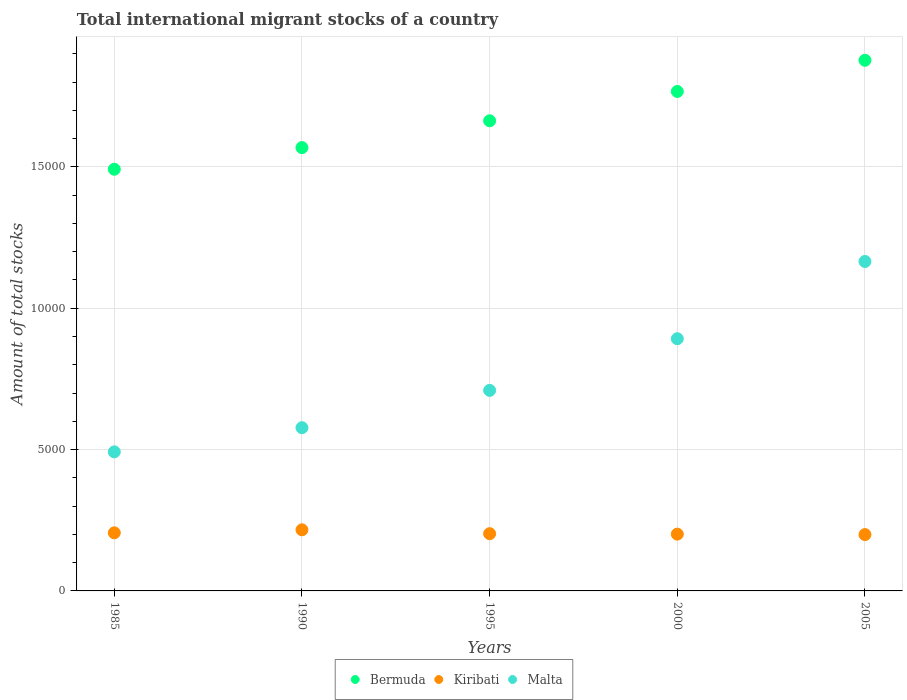What is the amount of total stocks in in Kiribati in 1985?
Offer a very short reply. 2055. Across all years, what is the maximum amount of total stocks in in Bermuda?
Provide a succinct answer. 1.88e+04. What is the total amount of total stocks in in Malta in the graph?
Keep it short and to the point. 3.84e+04. What is the difference between the amount of total stocks in in Bermuda in 1985 and that in 2000?
Keep it short and to the point. -2751. What is the difference between the amount of total stocks in in Kiribati in 1985 and the amount of total stocks in in Bermuda in 2000?
Ensure brevity in your answer.  -1.56e+04. What is the average amount of total stocks in in Kiribati per year?
Your answer should be very brief. 2048.8. In the year 1985, what is the difference between the amount of total stocks in in Kiribati and amount of total stocks in in Malta?
Provide a short and direct response. -2864. In how many years, is the amount of total stocks in in Malta greater than 4000?
Your answer should be compact. 5. What is the ratio of the amount of total stocks in in Bermuda in 1985 to that in 2005?
Your response must be concise. 0.79. Is the amount of total stocks in in Malta in 1985 less than that in 1995?
Provide a succinct answer. Yes. Is the difference between the amount of total stocks in in Kiribati in 1985 and 2000 greater than the difference between the amount of total stocks in in Malta in 1985 and 2000?
Provide a short and direct response. Yes. What is the difference between the highest and the second highest amount of total stocks in in Bermuda?
Make the answer very short. 1103. What is the difference between the highest and the lowest amount of total stocks in in Bermuda?
Ensure brevity in your answer.  3854. Is the sum of the amount of total stocks in in Bermuda in 1995 and 2005 greater than the maximum amount of total stocks in in Kiribati across all years?
Provide a short and direct response. Yes. Does the amount of total stocks in in Kiribati monotonically increase over the years?
Provide a succinct answer. No. Is the amount of total stocks in in Bermuda strictly less than the amount of total stocks in in Malta over the years?
Make the answer very short. No. How many dotlines are there?
Ensure brevity in your answer.  3. How many years are there in the graph?
Provide a succinct answer. 5. Are the values on the major ticks of Y-axis written in scientific E-notation?
Offer a terse response. No. How many legend labels are there?
Make the answer very short. 3. What is the title of the graph?
Provide a succinct answer. Total international migrant stocks of a country. Does "Hungary" appear as one of the legend labels in the graph?
Keep it short and to the point. No. What is the label or title of the X-axis?
Your answer should be very brief. Years. What is the label or title of the Y-axis?
Give a very brief answer. Amount of total stocks. What is the Amount of total stocks of Bermuda in 1985?
Ensure brevity in your answer.  1.49e+04. What is the Amount of total stocks in Kiribati in 1985?
Your answer should be very brief. 2055. What is the Amount of total stocks of Malta in 1985?
Offer a terse response. 4919. What is the Amount of total stocks in Bermuda in 1990?
Ensure brevity in your answer.  1.57e+04. What is the Amount of total stocks of Kiribati in 1990?
Keep it short and to the point. 2162. What is the Amount of total stocks of Malta in 1990?
Give a very brief answer. 5774. What is the Amount of total stocks in Bermuda in 1995?
Your response must be concise. 1.66e+04. What is the Amount of total stocks of Kiribati in 1995?
Keep it short and to the point. 2025. What is the Amount of total stocks in Malta in 1995?
Provide a succinct answer. 7094. What is the Amount of total stocks in Bermuda in 2000?
Your response must be concise. 1.77e+04. What is the Amount of total stocks in Kiribati in 2000?
Offer a terse response. 2009. What is the Amount of total stocks in Malta in 2000?
Ensure brevity in your answer.  8922. What is the Amount of total stocks in Bermuda in 2005?
Give a very brief answer. 1.88e+04. What is the Amount of total stocks in Kiribati in 2005?
Your answer should be very brief. 1993. What is the Amount of total stocks in Malta in 2005?
Provide a short and direct response. 1.17e+04. Across all years, what is the maximum Amount of total stocks in Bermuda?
Provide a succinct answer. 1.88e+04. Across all years, what is the maximum Amount of total stocks in Kiribati?
Keep it short and to the point. 2162. Across all years, what is the maximum Amount of total stocks in Malta?
Give a very brief answer. 1.17e+04. Across all years, what is the minimum Amount of total stocks of Bermuda?
Your answer should be very brief. 1.49e+04. Across all years, what is the minimum Amount of total stocks in Kiribati?
Provide a succinct answer. 1993. Across all years, what is the minimum Amount of total stocks in Malta?
Offer a very short reply. 4919. What is the total Amount of total stocks in Bermuda in the graph?
Keep it short and to the point. 8.37e+04. What is the total Amount of total stocks of Kiribati in the graph?
Offer a very short reply. 1.02e+04. What is the total Amount of total stocks of Malta in the graph?
Give a very brief answer. 3.84e+04. What is the difference between the Amount of total stocks in Bermuda in 1985 and that in 1990?
Give a very brief answer. -766. What is the difference between the Amount of total stocks in Kiribati in 1985 and that in 1990?
Ensure brevity in your answer.  -107. What is the difference between the Amount of total stocks in Malta in 1985 and that in 1990?
Your answer should be compact. -855. What is the difference between the Amount of total stocks of Bermuda in 1985 and that in 1995?
Ensure brevity in your answer.  -1714. What is the difference between the Amount of total stocks in Malta in 1985 and that in 1995?
Offer a terse response. -2175. What is the difference between the Amount of total stocks of Bermuda in 1985 and that in 2000?
Your answer should be compact. -2751. What is the difference between the Amount of total stocks in Malta in 1985 and that in 2000?
Make the answer very short. -4003. What is the difference between the Amount of total stocks of Bermuda in 1985 and that in 2005?
Give a very brief answer. -3854. What is the difference between the Amount of total stocks in Kiribati in 1985 and that in 2005?
Keep it short and to the point. 62. What is the difference between the Amount of total stocks in Malta in 1985 and that in 2005?
Your answer should be very brief. -6735. What is the difference between the Amount of total stocks in Bermuda in 1990 and that in 1995?
Your answer should be compact. -948. What is the difference between the Amount of total stocks in Kiribati in 1990 and that in 1995?
Provide a succinct answer. 137. What is the difference between the Amount of total stocks of Malta in 1990 and that in 1995?
Offer a very short reply. -1320. What is the difference between the Amount of total stocks in Bermuda in 1990 and that in 2000?
Give a very brief answer. -1985. What is the difference between the Amount of total stocks in Kiribati in 1990 and that in 2000?
Give a very brief answer. 153. What is the difference between the Amount of total stocks of Malta in 1990 and that in 2000?
Your answer should be compact. -3148. What is the difference between the Amount of total stocks of Bermuda in 1990 and that in 2005?
Your response must be concise. -3088. What is the difference between the Amount of total stocks in Kiribati in 1990 and that in 2005?
Keep it short and to the point. 169. What is the difference between the Amount of total stocks of Malta in 1990 and that in 2005?
Make the answer very short. -5880. What is the difference between the Amount of total stocks of Bermuda in 1995 and that in 2000?
Ensure brevity in your answer.  -1037. What is the difference between the Amount of total stocks in Kiribati in 1995 and that in 2000?
Provide a succinct answer. 16. What is the difference between the Amount of total stocks of Malta in 1995 and that in 2000?
Give a very brief answer. -1828. What is the difference between the Amount of total stocks in Bermuda in 1995 and that in 2005?
Offer a terse response. -2140. What is the difference between the Amount of total stocks of Kiribati in 1995 and that in 2005?
Make the answer very short. 32. What is the difference between the Amount of total stocks in Malta in 1995 and that in 2005?
Your answer should be very brief. -4560. What is the difference between the Amount of total stocks in Bermuda in 2000 and that in 2005?
Give a very brief answer. -1103. What is the difference between the Amount of total stocks in Malta in 2000 and that in 2005?
Ensure brevity in your answer.  -2732. What is the difference between the Amount of total stocks in Bermuda in 1985 and the Amount of total stocks in Kiribati in 1990?
Provide a succinct answer. 1.28e+04. What is the difference between the Amount of total stocks of Bermuda in 1985 and the Amount of total stocks of Malta in 1990?
Provide a short and direct response. 9143. What is the difference between the Amount of total stocks in Kiribati in 1985 and the Amount of total stocks in Malta in 1990?
Your answer should be compact. -3719. What is the difference between the Amount of total stocks of Bermuda in 1985 and the Amount of total stocks of Kiribati in 1995?
Ensure brevity in your answer.  1.29e+04. What is the difference between the Amount of total stocks in Bermuda in 1985 and the Amount of total stocks in Malta in 1995?
Keep it short and to the point. 7823. What is the difference between the Amount of total stocks in Kiribati in 1985 and the Amount of total stocks in Malta in 1995?
Make the answer very short. -5039. What is the difference between the Amount of total stocks in Bermuda in 1985 and the Amount of total stocks in Kiribati in 2000?
Offer a very short reply. 1.29e+04. What is the difference between the Amount of total stocks in Bermuda in 1985 and the Amount of total stocks in Malta in 2000?
Provide a short and direct response. 5995. What is the difference between the Amount of total stocks in Kiribati in 1985 and the Amount of total stocks in Malta in 2000?
Your answer should be very brief. -6867. What is the difference between the Amount of total stocks in Bermuda in 1985 and the Amount of total stocks in Kiribati in 2005?
Your answer should be compact. 1.29e+04. What is the difference between the Amount of total stocks of Bermuda in 1985 and the Amount of total stocks of Malta in 2005?
Give a very brief answer. 3263. What is the difference between the Amount of total stocks of Kiribati in 1985 and the Amount of total stocks of Malta in 2005?
Provide a short and direct response. -9599. What is the difference between the Amount of total stocks in Bermuda in 1990 and the Amount of total stocks in Kiribati in 1995?
Provide a succinct answer. 1.37e+04. What is the difference between the Amount of total stocks of Bermuda in 1990 and the Amount of total stocks of Malta in 1995?
Make the answer very short. 8589. What is the difference between the Amount of total stocks of Kiribati in 1990 and the Amount of total stocks of Malta in 1995?
Your answer should be compact. -4932. What is the difference between the Amount of total stocks in Bermuda in 1990 and the Amount of total stocks in Kiribati in 2000?
Offer a terse response. 1.37e+04. What is the difference between the Amount of total stocks in Bermuda in 1990 and the Amount of total stocks in Malta in 2000?
Keep it short and to the point. 6761. What is the difference between the Amount of total stocks of Kiribati in 1990 and the Amount of total stocks of Malta in 2000?
Ensure brevity in your answer.  -6760. What is the difference between the Amount of total stocks in Bermuda in 1990 and the Amount of total stocks in Kiribati in 2005?
Provide a short and direct response. 1.37e+04. What is the difference between the Amount of total stocks of Bermuda in 1990 and the Amount of total stocks of Malta in 2005?
Offer a terse response. 4029. What is the difference between the Amount of total stocks in Kiribati in 1990 and the Amount of total stocks in Malta in 2005?
Your answer should be very brief. -9492. What is the difference between the Amount of total stocks of Bermuda in 1995 and the Amount of total stocks of Kiribati in 2000?
Provide a short and direct response. 1.46e+04. What is the difference between the Amount of total stocks in Bermuda in 1995 and the Amount of total stocks in Malta in 2000?
Provide a succinct answer. 7709. What is the difference between the Amount of total stocks of Kiribati in 1995 and the Amount of total stocks of Malta in 2000?
Your answer should be compact. -6897. What is the difference between the Amount of total stocks in Bermuda in 1995 and the Amount of total stocks in Kiribati in 2005?
Your answer should be very brief. 1.46e+04. What is the difference between the Amount of total stocks of Bermuda in 1995 and the Amount of total stocks of Malta in 2005?
Your answer should be very brief. 4977. What is the difference between the Amount of total stocks of Kiribati in 1995 and the Amount of total stocks of Malta in 2005?
Ensure brevity in your answer.  -9629. What is the difference between the Amount of total stocks of Bermuda in 2000 and the Amount of total stocks of Kiribati in 2005?
Your answer should be very brief. 1.57e+04. What is the difference between the Amount of total stocks of Bermuda in 2000 and the Amount of total stocks of Malta in 2005?
Provide a short and direct response. 6014. What is the difference between the Amount of total stocks of Kiribati in 2000 and the Amount of total stocks of Malta in 2005?
Provide a succinct answer. -9645. What is the average Amount of total stocks in Bermuda per year?
Offer a terse response. 1.67e+04. What is the average Amount of total stocks of Kiribati per year?
Offer a very short reply. 2048.8. What is the average Amount of total stocks in Malta per year?
Your response must be concise. 7672.6. In the year 1985, what is the difference between the Amount of total stocks of Bermuda and Amount of total stocks of Kiribati?
Offer a very short reply. 1.29e+04. In the year 1985, what is the difference between the Amount of total stocks in Bermuda and Amount of total stocks in Malta?
Give a very brief answer. 9998. In the year 1985, what is the difference between the Amount of total stocks in Kiribati and Amount of total stocks in Malta?
Ensure brevity in your answer.  -2864. In the year 1990, what is the difference between the Amount of total stocks in Bermuda and Amount of total stocks in Kiribati?
Provide a succinct answer. 1.35e+04. In the year 1990, what is the difference between the Amount of total stocks in Bermuda and Amount of total stocks in Malta?
Your response must be concise. 9909. In the year 1990, what is the difference between the Amount of total stocks of Kiribati and Amount of total stocks of Malta?
Make the answer very short. -3612. In the year 1995, what is the difference between the Amount of total stocks of Bermuda and Amount of total stocks of Kiribati?
Ensure brevity in your answer.  1.46e+04. In the year 1995, what is the difference between the Amount of total stocks of Bermuda and Amount of total stocks of Malta?
Ensure brevity in your answer.  9537. In the year 1995, what is the difference between the Amount of total stocks in Kiribati and Amount of total stocks in Malta?
Make the answer very short. -5069. In the year 2000, what is the difference between the Amount of total stocks of Bermuda and Amount of total stocks of Kiribati?
Your answer should be very brief. 1.57e+04. In the year 2000, what is the difference between the Amount of total stocks in Bermuda and Amount of total stocks in Malta?
Your response must be concise. 8746. In the year 2000, what is the difference between the Amount of total stocks in Kiribati and Amount of total stocks in Malta?
Offer a very short reply. -6913. In the year 2005, what is the difference between the Amount of total stocks in Bermuda and Amount of total stocks in Kiribati?
Provide a short and direct response. 1.68e+04. In the year 2005, what is the difference between the Amount of total stocks of Bermuda and Amount of total stocks of Malta?
Your answer should be very brief. 7117. In the year 2005, what is the difference between the Amount of total stocks of Kiribati and Amount of total stocks of Malta?
Offer a terse response. -9661. What is the ratio of the Amount of total stocks in Bermuda in 1985 to that in 1990?
Offer a very short reply. 0.95. What is the ratio of the Amount of total stocks of Kiribati in 1985 to that in 1990?
Make the answer very short. 0.95. What is the ratio of the Amount of total stocks of Malta in 1985 to that in 1990?
Keep it short and to the point. 0.85. What is the ratio of the Amount of total stocks in Bermuda in 1985 to that in 1995?
Keep it short and to the point. 0.9. What is the ratio of the Amount of total stocks of Kiribati in 1985 to that in 1995?
Offer a very short reply. 1.01. What is the ratio of the Amount of total stocks in Malta in 1985 to that in 1995?
Give a very brief answer. 0.69. What is the ratio of the Amount of total stocks in Bermuda in 1985 to that in 2000?
Ensure brevity in your answer.  0.84. What is the ratio of the Amount of total stocks of Kiribati in 1985 to that in 2000?
Offer a terse response. 1.02. What is the ratio of the Amount of total stocks of Malta in 1985 to that in 2000?
Your answer should be compact. 0.55. What is the ratio of the Amount of total stocks of Bermuda in 1985 to that in 2005?
Keep it short and to the point. 0.79. What is the ratio of the Amount of total stocks in Kiribati in 1985 to that in 2005?
Ensure brevity in your answer.  1.03. What is the ratio of the Amount of total stocks of Malta in 1985 to that in 2005?
Keep it short and to the point. 0.42. What is the ratio of the Amount of total stocks of Bermuda in 1990 to that in 1995?
Your answer should be very brief. 0.94. What is the ratio of the Amount of total stocks in Kiribati in 1990 to that in 1995?
Your answer should be compact. 1.07. What is the ratio of the Amount of total stocks in Malta in 1990 to that in 1995?
Your response must be concise. 0.81. What is the ratio of the Amount of total stocks of Bermuda in 1990 to that in 2000?
Give a very brief answer. 0.89. What is the ratio of the Amount of total stocks of Kiribati in 1990 to that in 2000?
Ensure brevity in your answer.  1.08. What is the ratio of the Amount of total stocks of Malta in 1990 to that in 2000?
Provide a succinct answer. 0.65. What is the ratio of the Amount of total stocks of Bermuda in 1990 to that in 2005?
Offer a terse response. 0.84. What is the ratio of the Amount of total stocks in Kiribati in 1990 to that in 2005?
Provide a succinct answer. 1.08. What is the ratio of the Amount of total stocks of Malta in 1990 to that in 2005?
Your answer should be compact. 0.5. What is the ratio of the Amount of total stocks in Bermuda in 1995 to that in 2000?
Offer a very short reply. 0.94. What is the ratio of the Amount of total stocks in Malta in 1995 to that in 2000?
Make the answer very short. 0.8. What is the ratio of the Amount of total stocks of Bermuda in 1995 to that in 2005?
Your answer should be compact. 0.89. What is the ratio of the Amount of total stocks of Kiribati in 1995 to that in 2005?
Your response must be concise. 1.02. What is the ratio of the Amount of total stocks of Malta in 1995 to that in 2005?
Provide a short and direct response. 0.61. What is the ratio of the Amount of total stocks of Bermuda in 2000 to that in 2005?
Give a very brief answer. 0.94. What is the ratio of the Amount of total stocks of Malta in 2000 to that in 2005?
Your answer should be very brief. 0.77. What is the difference between the highest and the second highest Amount of total stocks of Bermuda?
Provide a succinct answer. 1103. What is the difference between the highest and the second highest Amount of total stocks in Kiribati?
Make the answer very short. 107. What is the difference between the highest and the second highest Amount of total stocks in Malta?
Provide a succinct answer. 2732. What is the difference between the highest and the lowest Amount of total stocks of Bermuda?
Give a very brief answer. 3854. What is the difference between the highest and the lowest Amount of total stocks of Kiribati?
Your answer should be very brief. 169. What is the difference between the highest and the lowest Amount of total stocks of Malta?
Provide a succinct answer. 6735. 